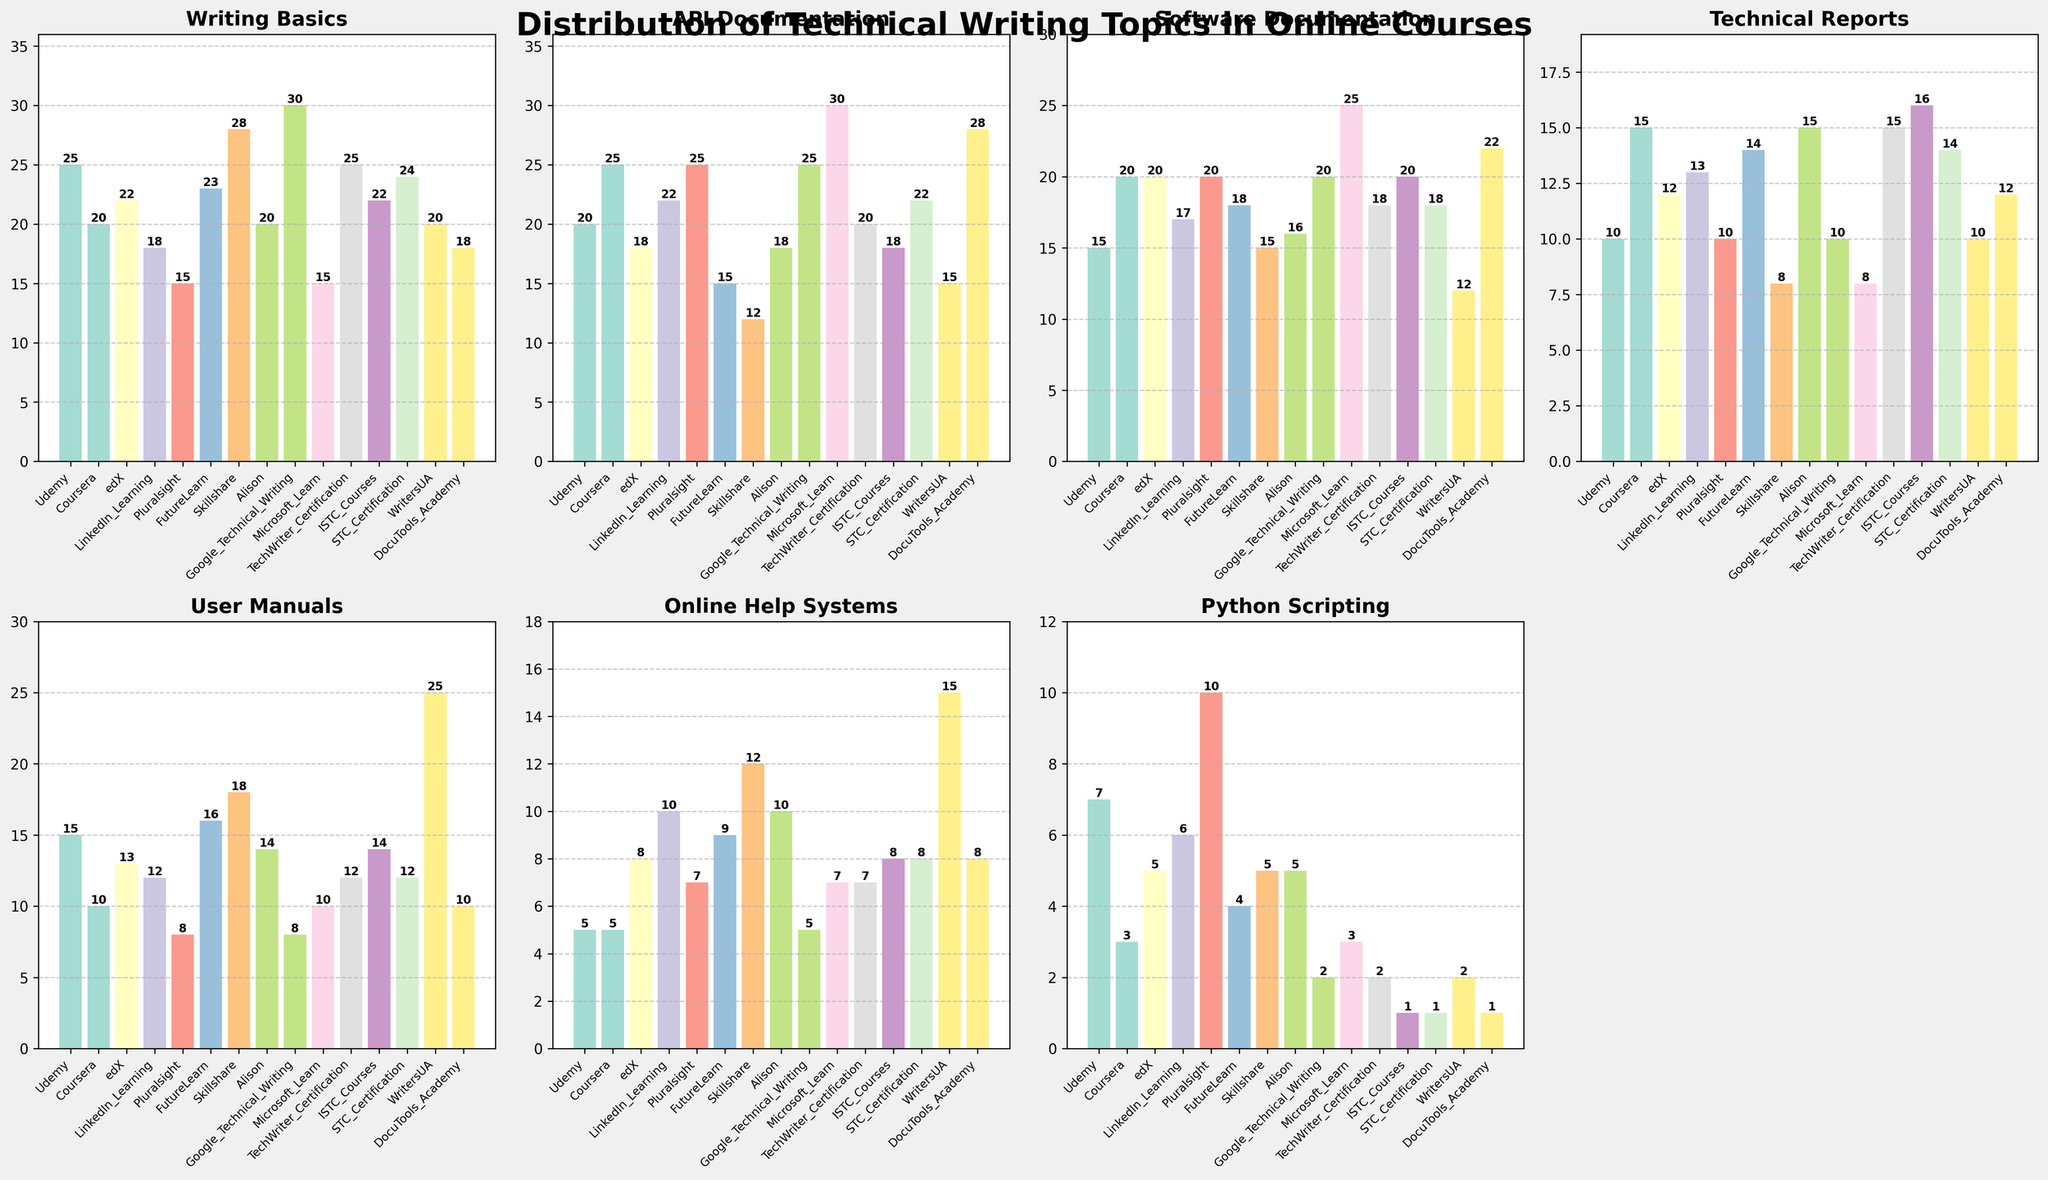Which topic has the highest value in Coursera? First, locate the subplot labeled 'Coursera'. Then, identify the tallest bar in this subplot.
Answer: API Documentation What's the difference in the number of courses covering Python Scripting between Pluralsight and Udemy? Identify the values for Python Scripting in Pluralsight and Udemy subplots. Subtract Udemy's value (7) from Pluralsight's value (10).
Answer: 3 Which platform has the least coverage of SaltStack Usage? Locate the subplot for SaltStack Usage. Identify the shortest bar among all platforms.
Answer: Google Technical Writing What is the average value for Technical Reports across all platforms? Sum the values for Technical Reports from all platforms and divide by the number of platforms. (10+15+12+13+10+14+8+15+10+8+15+16+14+12) / 14 = 12.6
Answer: 12.6 Which topic has the most even distribution across all platforms? Evaluate each topic's bars across all subplots and find the one with the least variation in heights.
Answer: Technical Reports Is 'Writing Basics' more frequently covered in Udemy or LinkedIn Learning? Compare the height of the bars for 'Writing Basics' in Udemy and LinkedIn Learning subplots. Udemy has 25 and LinkedIn Learning has 18.
Answer: Udemy How many platforms have more than 20 courses on User Manuals? Count the number of platforms with User Manuals values greater than 20. Only Skillshare has more than 20 courses.
Answer: 1 What is the total number of courses on Software Documentation offered by edX and Coursera combined? Add the values for Software Documentation from edX (20) and Coursera (20).
Answer: 40 Which platform offers the highest number of courses on API Documentation? Identify the subplot for API Documentation and find the platform with the tallest bar.
Answer: Microsoft Learn 